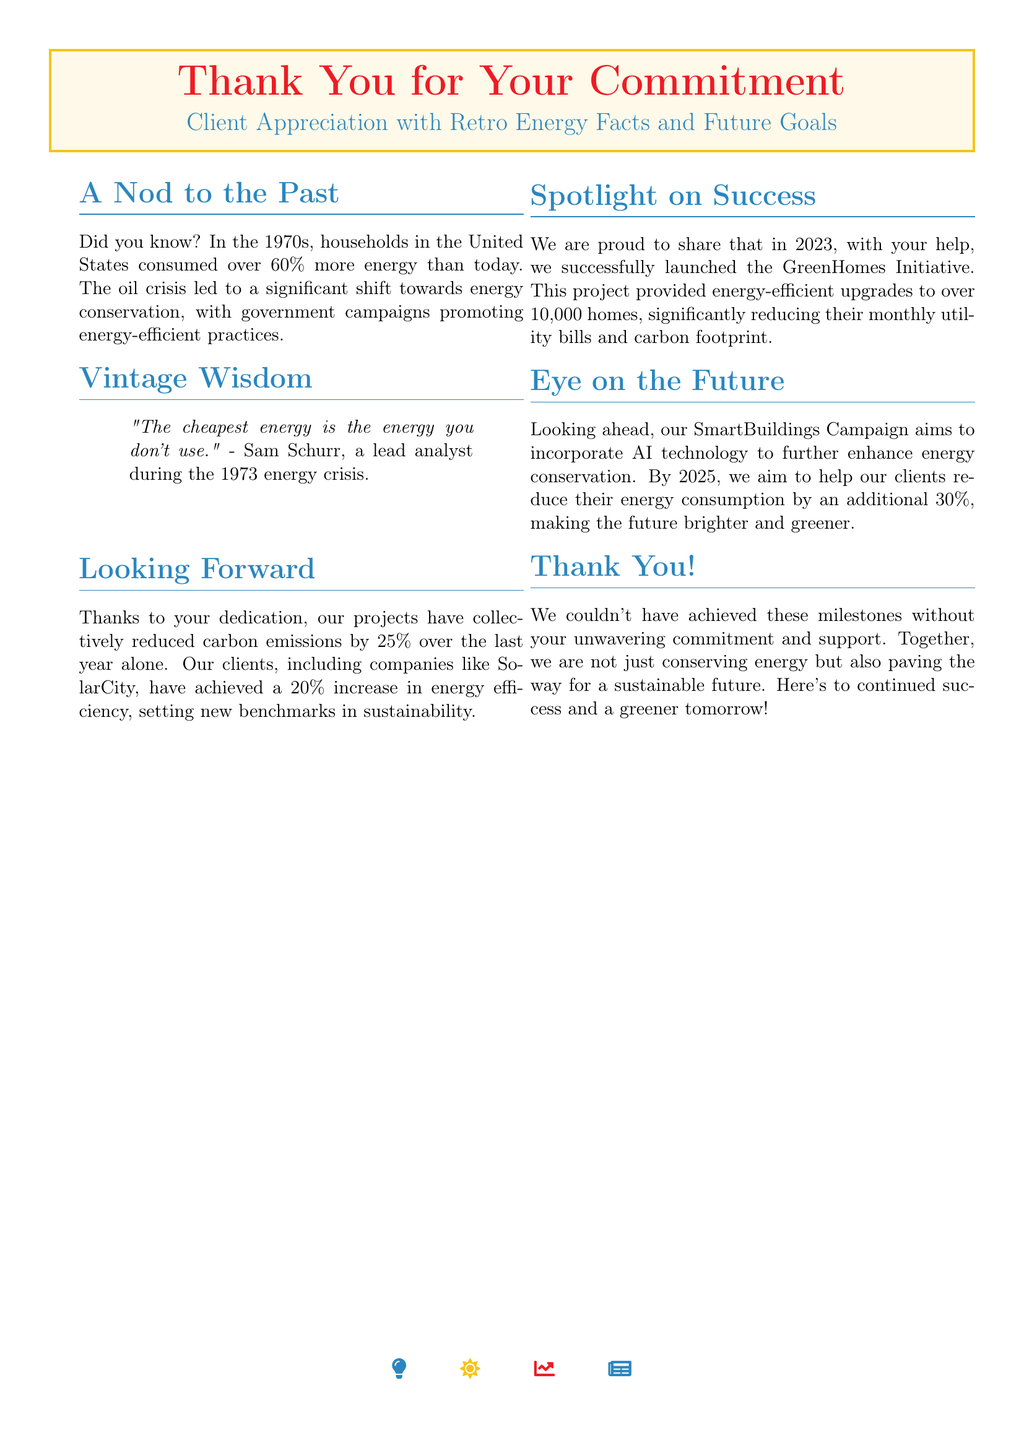What was the percentage increase in energy consumption in the 1970s? The document states that households in the United States consumed over 60% more energy than today in the 1970s.
Answer: 60% Who made the statement about the cheapest energy? The quote in the document attributes the statement to Sam Schurr, a lead analyst during the 1973 energy crisis.
Answer: Sam Schurr What was the reduction in carbon emissions achieved over the last year? The document mentions that projects have collectively reduced carbon emissions by 25% over the last year.
Answer: 25% How many homes received energy-efficient upgrades through the GreenHomes Initiative? The document states that over 10,000 homes were provided energy-efficient upgrades as part of the initiative.
Answer: 10,000 What is the goal for energy consumption reduction by 2025? The document indicates that the goal is to help clients reduce their energy consumption by an additional 30% by 2025.
Answer: 30% What campaign aims to incorporate AI technology? The document refers to the SmartBuildings Campaign as the initiative that aims to incorporate AI technology.
Answer: SmartBuildings Campaign What is the main theme of this greeting card? The greeting card emphasizes client appreciation, retro energy facts, and future goals.
Answer: Client appreciation What metric signifies success in sustainability mentioned in the document? The document highlights a 20% increase in energy efficiency achieved by clients as a success metric.
Answer: 20% 